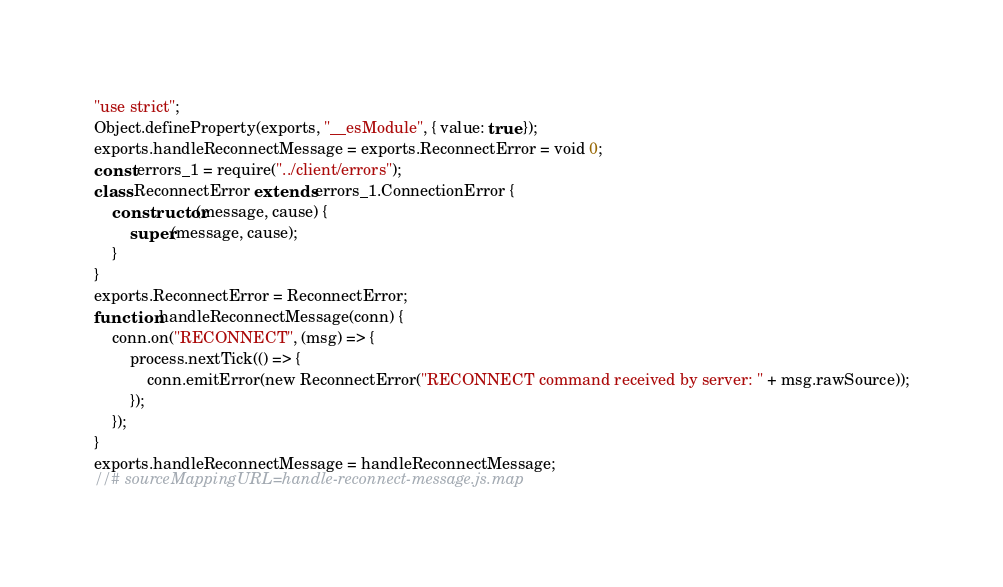Convert code to text. <code><loc_0><loc_0><loc_500><loc_500><_JavaScript_>"use strict";
Object.defineProperty(exports, "__esModule", { value: true });
exports.handleReconnectMessage = exports.ReconnectError = void 0;
const errors_1 = require("../client/errors");
class ReconnectError extends errors_1.ConnectionError {
    constructor(message, cause) {
        super(message, cause);
    }
}
exports.ReconnectError = ReconnectError;
function handleReconnectMessage(conn) {
    conn.on("RECONNECT", (msg) => {
        process.nextTick(() => {
            conn.emitError(new ReconnectError("RECONNECT command received by server: " + msg.rawSource));
        });
    });
}
exports.handleReconnectMessage = handleReconnectMessage;
//# sourceMappingURL=handle-reconnect-message.js.map</code> 